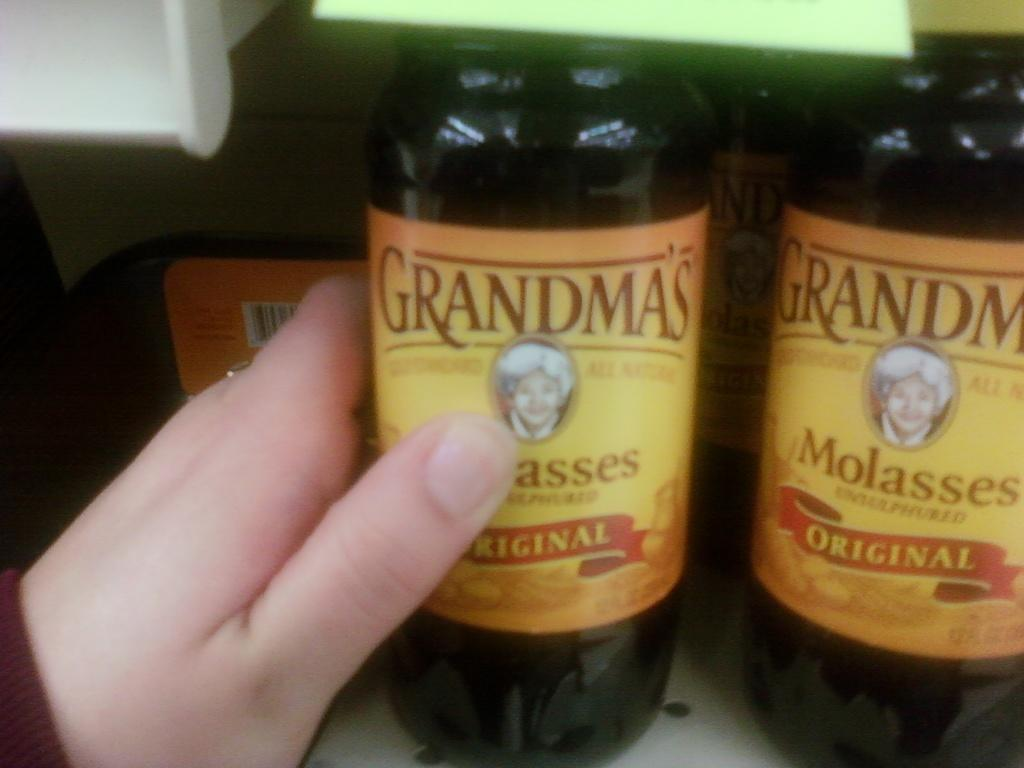Provide a one-sentence caption for the provided image. A hand reaches for a bottle of Grandma's molasses. 